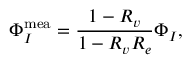Convert formula to latex. <formula><loc_0><loc_0><loc_500><loc_500>\Phi _ { I } ^ { m e a } = \frac { 1 - R _ { v } } { 1 - R _ { v } R _ { e } } \Phi _ { I } ,</formula> 